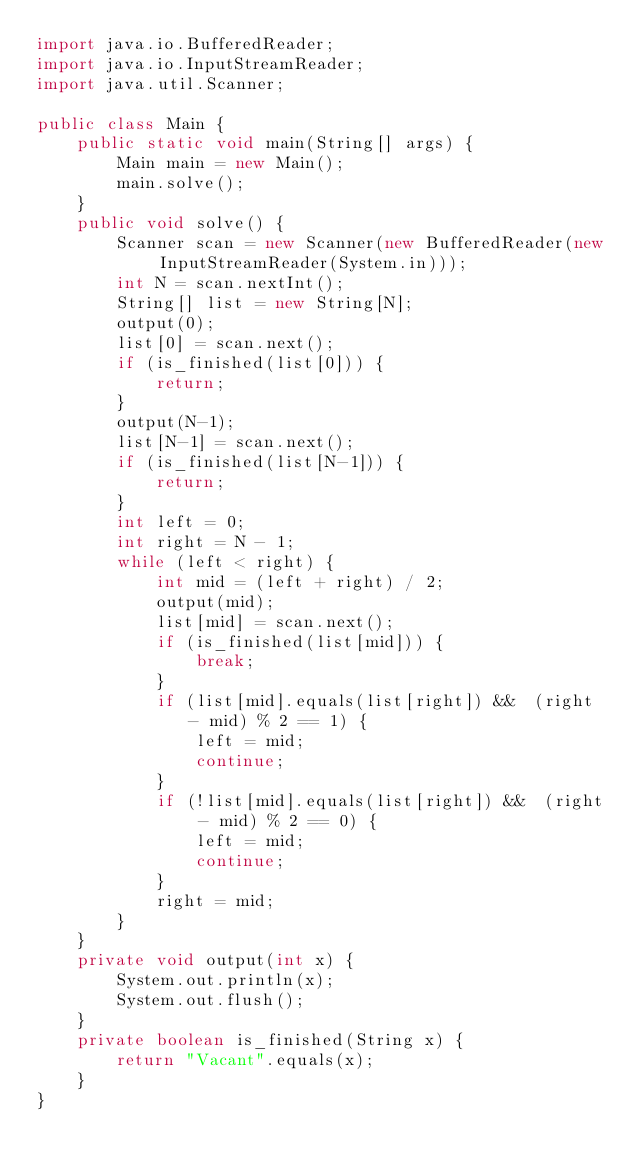Convert code to text. <code><loc_0><loc_0><loc_500><loc_500><_Java_>import java.io.BufferedReader;
import java.io.InputStreamReader;
import java.util.Scanner;

public class Main {
    public static void main(String[] args) {
        Main main = new Main();
        main.solve();
    }
    public void solve() {
        Scanner scan = new Scanner(new BufferedReader(new InputStreamReader(System.in)));
        int N = scan.nextInt();
        String[] list = new String[N];
        output(0);
        list[0] = scan.next();
        if (is_finished(list[0])) {
            return;
        }
        output(N-1);
        list[N-1] = scan.next();
        if (is_finished(list[N-1])) {
            return;
        }
        int left = 0;
        int right = N - 1;
        while (left < right) {
            int mid = (left + right) / 2;
            output(mid);
            list[mid] = scan.next();
            if (is_finished(list[mid])) {
                break;
            }
            if (list[mid].equals(list[right]) &&  (right - mid) % 2 == 1) {
                left = mid;
                continue;
            }
            if (!list[mid].equals(list[right]) &&  (right - mid) % 2 == 0) {
                left = mid;
                continue;
            }
            right = mid;
        }
    }
    private void output(int x) {
        System.out.println(x);
        System.out.flush();
    }
    private boolean is_finished(String x) {
        return "Vacant".equals(x);
    }
}
</code> 